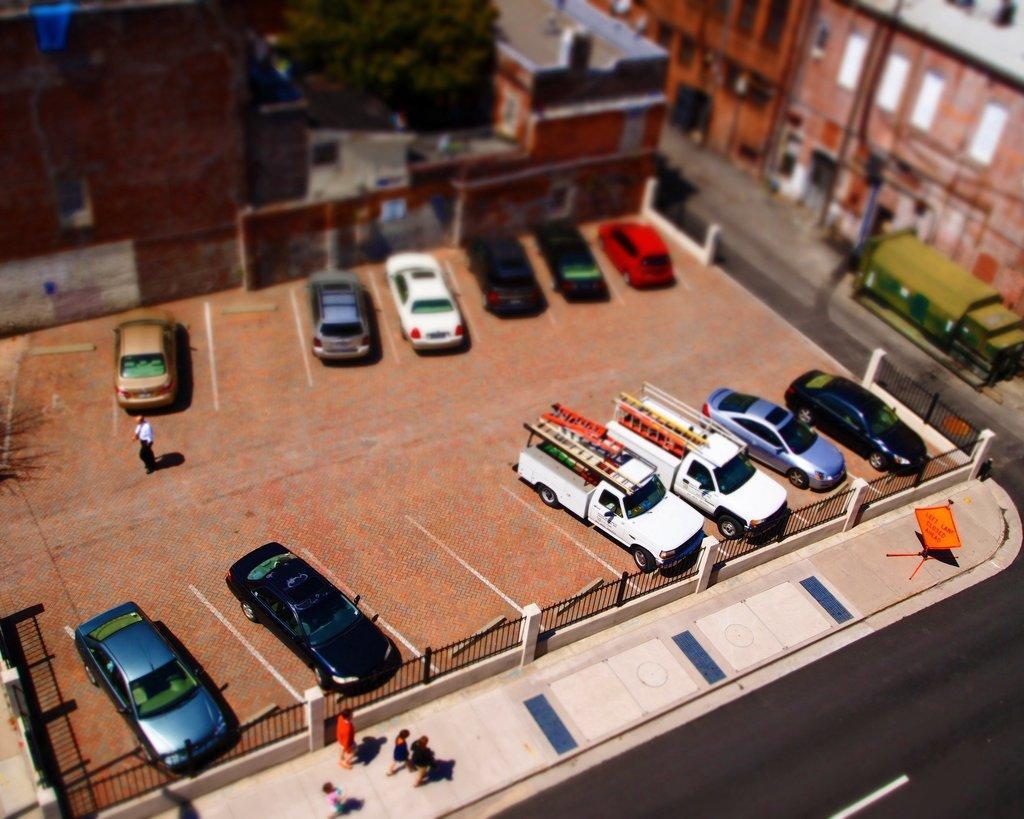In one or two sentences, can you explain what this image depicts? In this picture we can see trucks, cars and other objects in the parking. On the bottom we can see a group of persons walking near to the fencing. Here we can see yellow color board. On the right there is a truck near to the building. On the top we can see tree. 